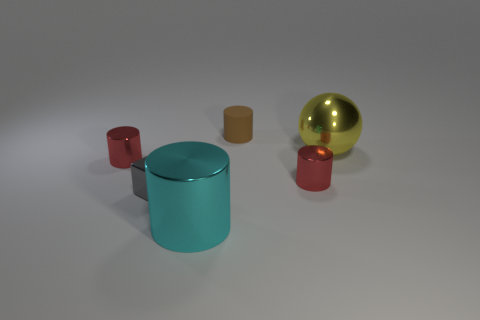Is there anything else that is the same shape as the big yellow thing?
Your response must be concise. No. There is a tiny red object to the right of the large shiny cylinder; what is its material?
Provide a succinct answer. Metal. There is a big thing that is the same shape as the tiny rubber object; what material is it?
Make the answer very short. Metal. Is there a yellow thing left of the big yellow thing that is to the right of the small block?
Your answer should be very brief. No. Does the brown thing have the same shape as the cyan shiny object?
Your answer should be compact. Yes. There is a big cyan thing that is the same material as the gray block; what shape is it?
Keep it short and to the point. Cylinder. There is a shiny object that is on the left side of the small metallic block; is it the same size as the block behind the large cyan object?
Your response must be concise. Yes. Is the number of cyan metallic cylinders that are in front of the small rubber cylinder greater than the number of small metallic cubes that are on the left side of the small cube?
Offer a very short reply. Yes. How many other objects are there of the same color as the small rubber thing?
Give a very brief answer. 0. There is a small metal cylinder that is on the left side of the brown matte cylinder; how many brown cylinders are behind it?
Keep it short and to the point. 1. 